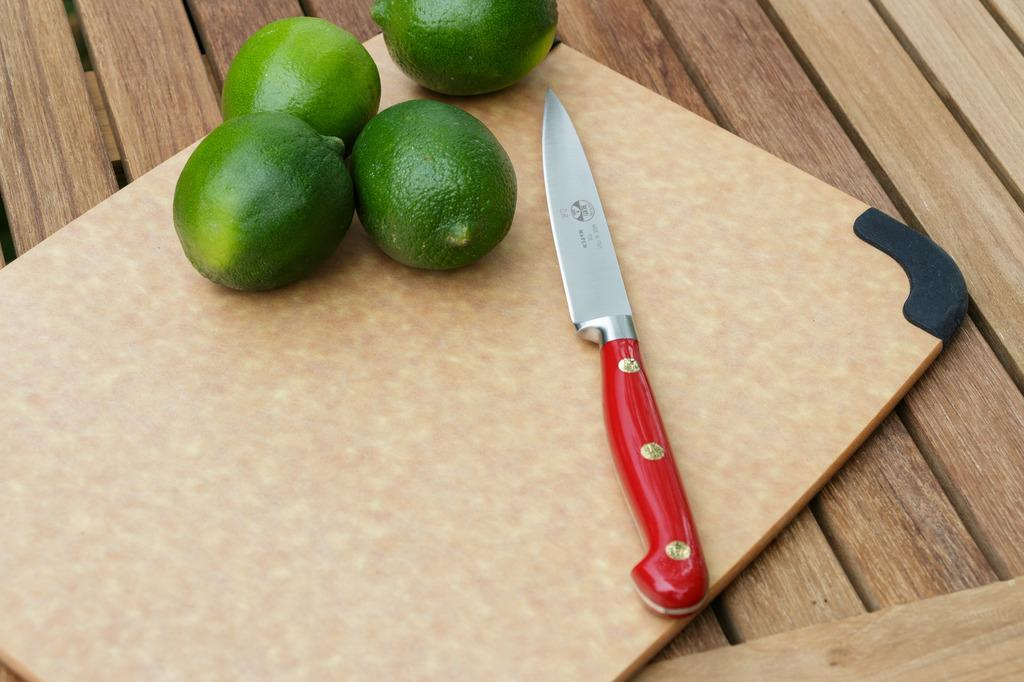What is present on the chopping board in the image? There is a red color knife and green color lemons on the chopping board in the image. What is the color of the knife on the chopping board? The knife on the chopping board is red in color. What type of fruit is on the chopping board? The fruit on the chopping board is green color lemons. What type of car can be seen parked next to the chopping board in the image? There is no car present in the image; it only features a chopping board with a red knife and green lemons. How does the horse contribute to the preparation of the lemons in the image? There is no horse present in the image; it only features a chopping board with a red knife and green lemons. 